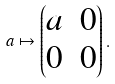Convert formula to latex. <formula><loc_0><loc_0><loc_500><loc_500>a \mapsto \begin{pmatrix} a & 0 \\ 0 & 0 \end{pmatrix} .</formula> 